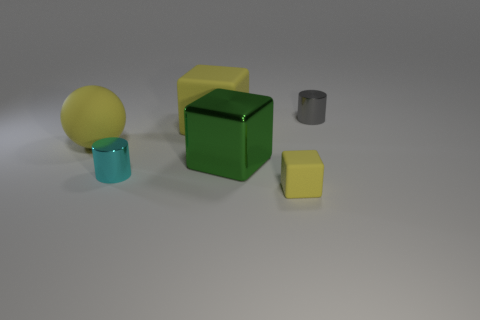Subtract all matte blocks. How many blocks are left? 1 Subtract all green blocks. How many blocks are left? 2 Add 3 shiny cylinders. How many objects exist? 9 Subtract all green spheres. How many yellow cubes are left? 2 Subtract 1 cylinders. How many cylinders are left? 1 Subtract all cylinders. How many objects are left? 4 Subtract all yellow blocks. Subtract all blue balls. How many blocks are left? 1 Subtract all big yellow matte spheres. Subtract all blue rubber objects. How many objects are left? 5 Add 2 rubber objects. How many rubber objects are left? 5 Add 2 small gray metal cylinders. How many small gray metal cylinders exist? 3 